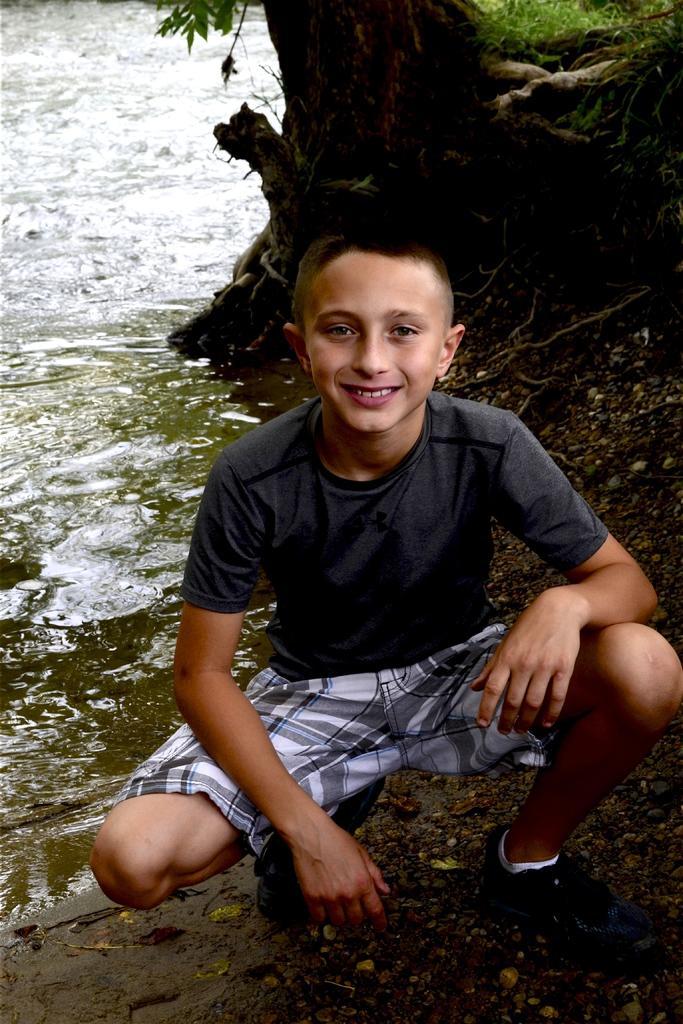Please provide a concise description of this image. In this image I can see a person wearing black and white colored dress is sitting. In the background I can see the water and a tree. 